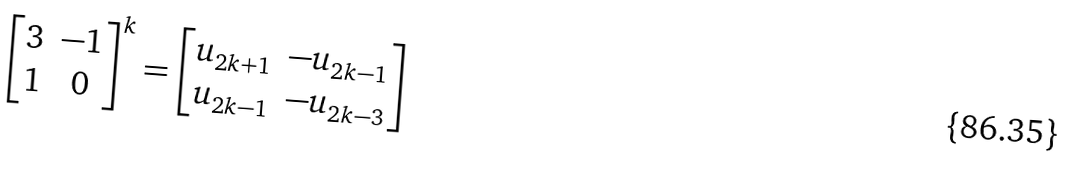Convert formula to latex. <formula><loc_0><loc_0><loc_500><loc_500>\left [ \begin{matrix} 3 & - 1 \\ 1 & 0 \end{matrix} \right ] ^ { k } = \left [ \begin{matrix} u _ { 2 k + 1 } & - u _ { 2 k - 1 } \\ u _ { 2 k - 1 } & - u _ { 2 k - 3 } \end{matrix} \right ]</formula> 